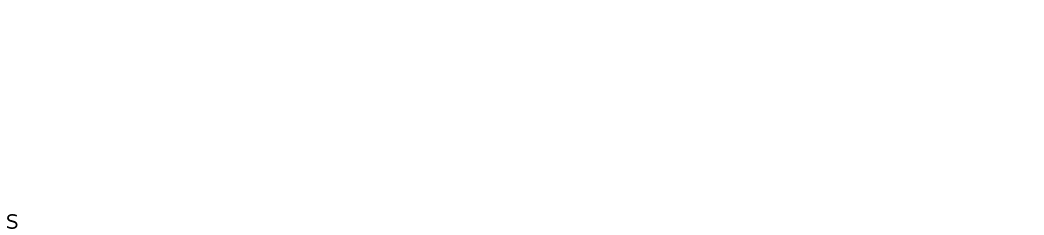Convert formula to latex. <formula><loc_0><loc_0><loc_500><loc_500>\begin{matrix} 0 & 1 & 0 & 0 & 0 & 0 \\ 1 & 0 & 0 & 0 & 0 & 0 \\ 0 & 0 & 0 & 1 & 0 & 0 \\ 0 & 0 & 1 & 0 & 0 & 0 \\ 0 & 0 & 0 & 0 & 0 & 1 \\ 0 & 0 & 0 & 0 & 1 & 0 \end{matrix}</formula> 